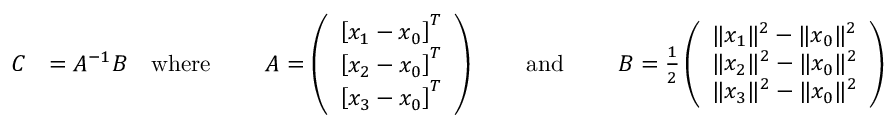Convert formula to latex. <formula><loc_0><loc_0><loc_500><loc_500>{ \begin{array} { r l r l r l r l r } { C } & { = A ^ { - 1 } B } & { w h e r e } & { \ } & { A = \left ( { \begin{array} { l } { \left [ x _ { 1 } - x _ { 0 } \right ] ^ { T } } \\ { \left [ x _ { 2 } - x _ { 0 } \right ] ^ { T } } \\ { \left [ x _ { 3 } - x _ { 0 } \right ] ^ { T } } \end{array} } \right ) } & { \ } & { a n d } & { \ } & { B = { \frac { 1 } { 2 } } \left ( { \begin{array} { l } { \| x _ { 1 } \| ^ { 2 } - \| x _ { 0 } \| ^ { 2 } } \\ { \| x _ { 2 } \| ^ { 2 } - \| x _ { 0 } \| ^ { 2 } } \\ { \| x _ { 3 } \| ^ { 2 } - \| x _ { 0 } \| ^ { 2 } } \end{array} } \right ) } \end{array} }</formula> 